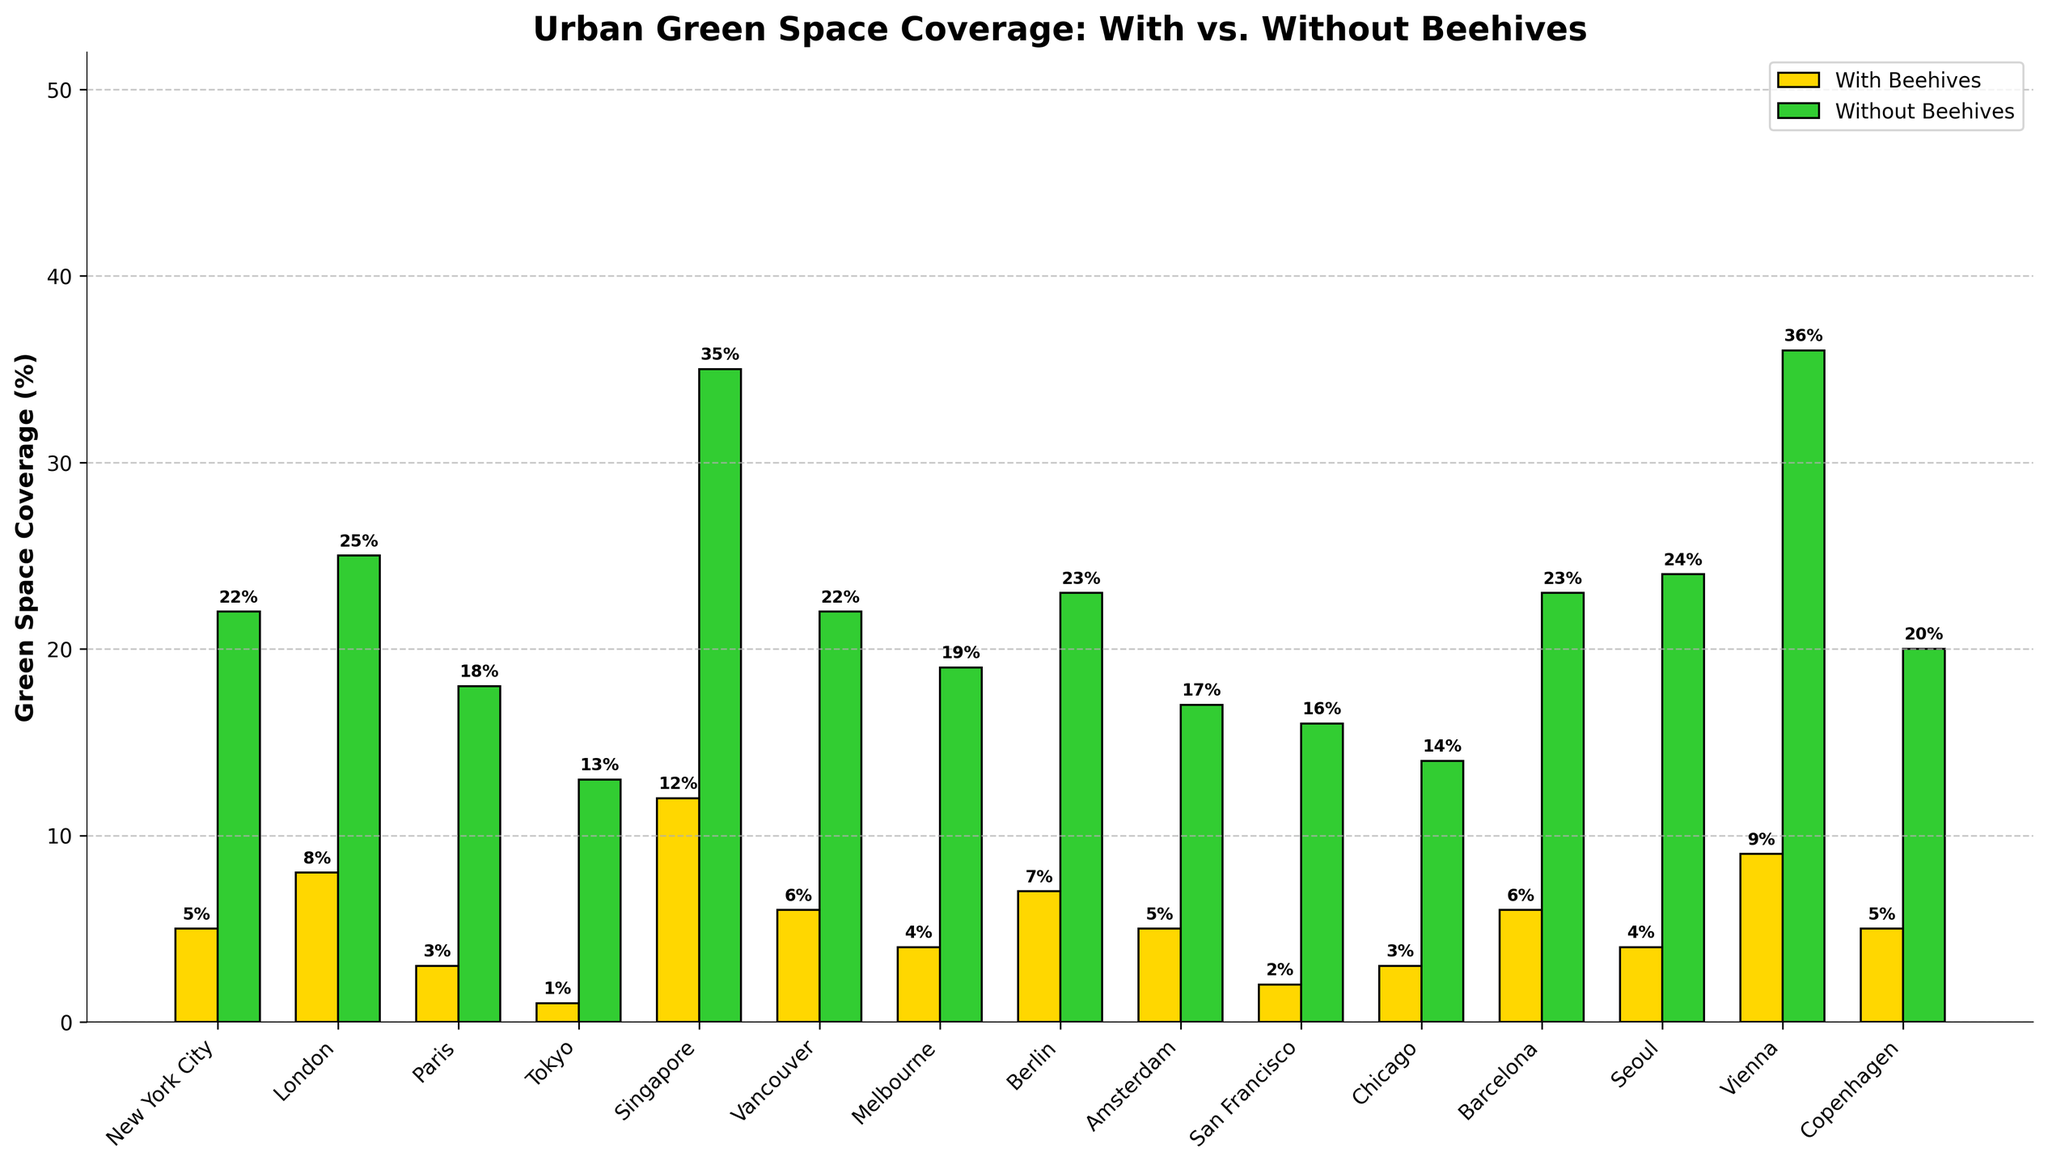Which city has the highest green space coverage with beehives? By examining the heights of the bars labeled 'With Beehives', we can see that Singapore has the highest value.
Answer: Singapore Which city has a larger difference between green space coverage with and without beehives, New York City or London? In New York City, the difference is 22% - 5% = 17%. In London, the difference is 25% - 8% = 17%. Thus, both cities have the same difference.
Answer: Both have the same difference Which city has the lowest green space coverage with beehives? By looking for the shortest bar labeled 'With Beehives', it is apparent that Tokyo has the lowest value.
Answer: Tokyo What is the combined green space coverage with beehives for Paris and Amsterdam? For Paris, it is 3%, and for Amsterdam, it is 5%. Adding them together, we get 3% + 5% = 8%.
Answer: 8% Which city has the highest green space coverage without beehives? By comparing the heights of the bars labeled 'Without Beehives', it is clear that Vienna has the highest value.
Answer: Vienna What is the average green space coverage with beehives across all cities? Sum all the 'With Beehives' values: 5%+8%+3%+1%+12%+6%+4%+7%+5%+2%+3%+6%+4%+9%+5% = 80%. There are 15 cities, so the average is 80%/15 ≈ 5.33%.
Answer: 5.33% Which city has a greater green space coverage increase with beehives compared to without beehives, Singapore or Vienna? In Singapore, the increase is 12% with beehives from a total of 47%. In Vienna, it is 9% with beehives from a total of 45%. Singapore has a higher increase than Vienna.
Answer: Singapore How does the green space coverage with beehives in San Francisco compare to that in Chicago? San Francisco's green space coverage with beehives is 2%, whereas Chicago's is 3%. Thus, Chicago's coverage is higher.
Answer: Chicago is higher What's the total green space coverage without beehives for the European cities listed? Adding the 'Without Beehives' values for the European cities (London, Paris, Berlin, Amsterdam, Vienna, Copenhagen, and Barcelona): 25% + 18% + 23% + 17% + 36% + 20% + 23% = 162%.
Answer: 162% Which city has the closest green space coverage with beehives among the cities New York City, London, and Paris? Comparing these cities, New York City has 5%, London has 8%, and Paris has 3%. New York City and Paris are closest to each other in terms of green space coverage with beehives (difference of 2%).
Answer: New York City and Paris 